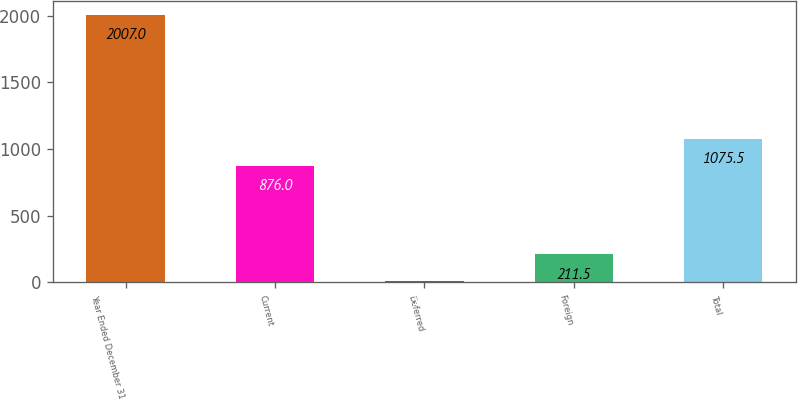Convert chart to OTSL. <chart><loc_0><loc_0><loc_500><loc_500><bar_chart><fcel>Year Ended December 31<fcel>Current<fcel>Deferred<fcel>Foreign<fcel>Total<nl><fcel>2007<fcel>876<fcel>12<fcel>211.5<fcel>1075.5<nl></chart> 